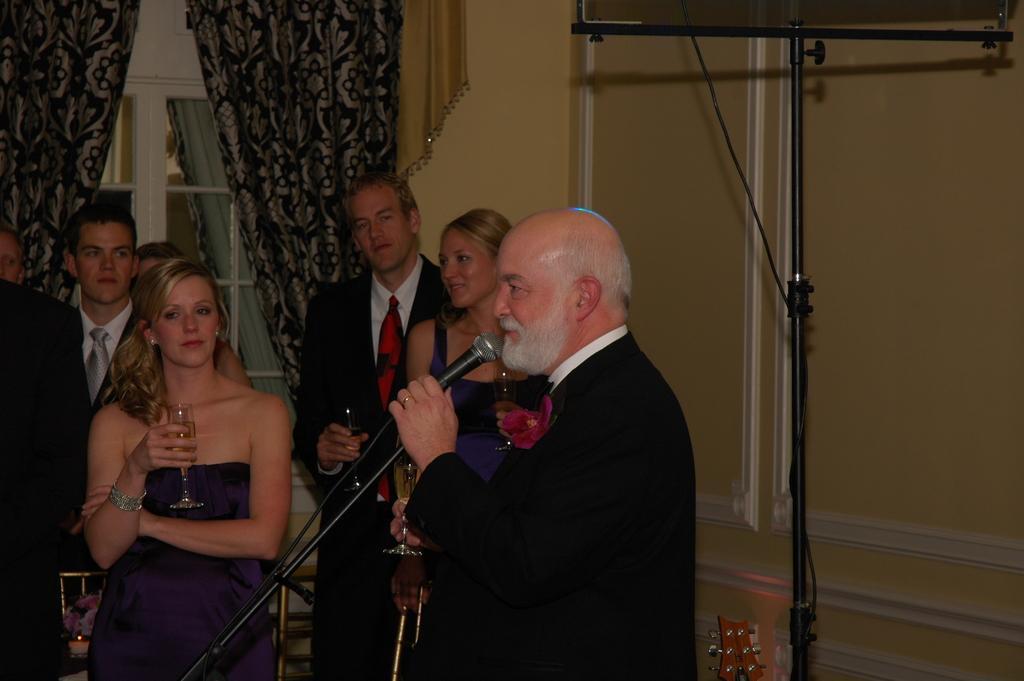Can you describe this image briefly? Man standing holding microphone,another persons are standing,there is curtain,door. 